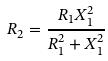Convert formula to latex. <formula><loc_0><loc_0><loc_500><loc_500>R _ { 2 } = \frac { R _ { 1 } X _ { 1 } ^ { 2 } } { R _ { 1 } ^ { 2 } + X _ { 1 } ^ { 2 } }</formula> 